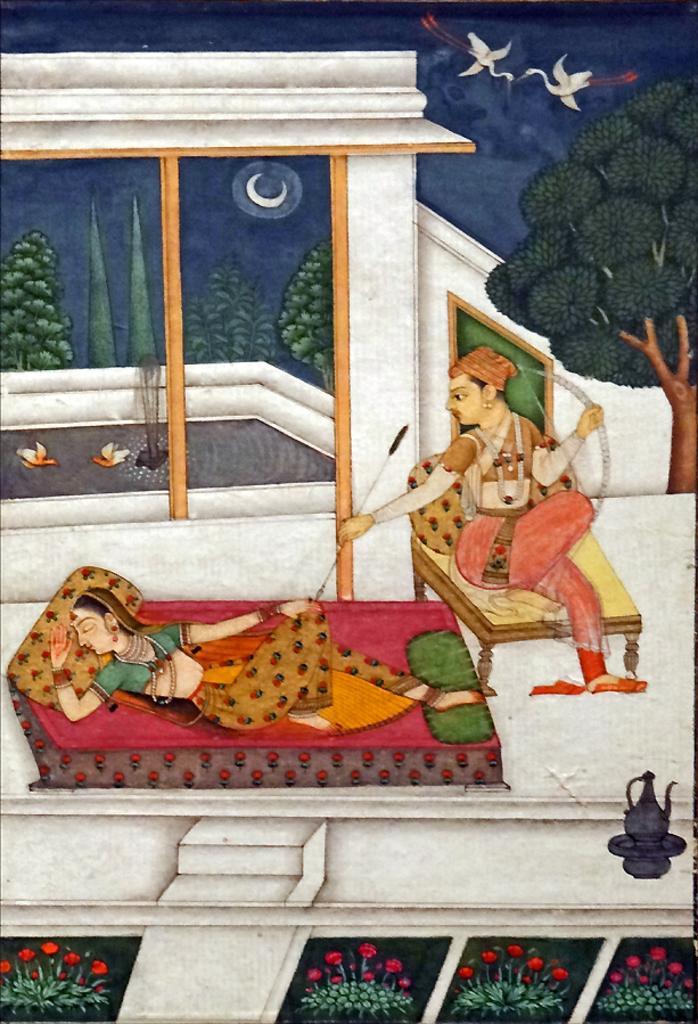Describe this image in one or two sentences. This is a painting. We can see a woman is sleeping on a bed and a man is sitting on a table and holding a bow and arrow. At the bottom we can see plants with flowers. In the background we can see trees, sky, moon and birds on the water. 